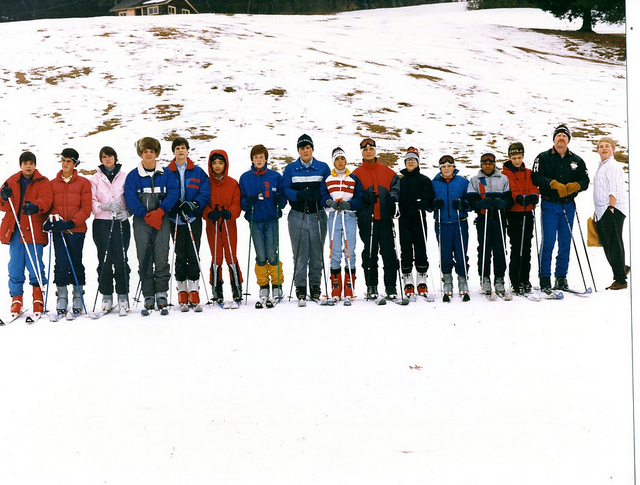<image>What kind of pet is tagging along? There is no pet tagging along in the image. What kind of pet is tagging along? I am not sure what kind of pet is tagging along. It can be seen 'no pet' or 'dog'. 